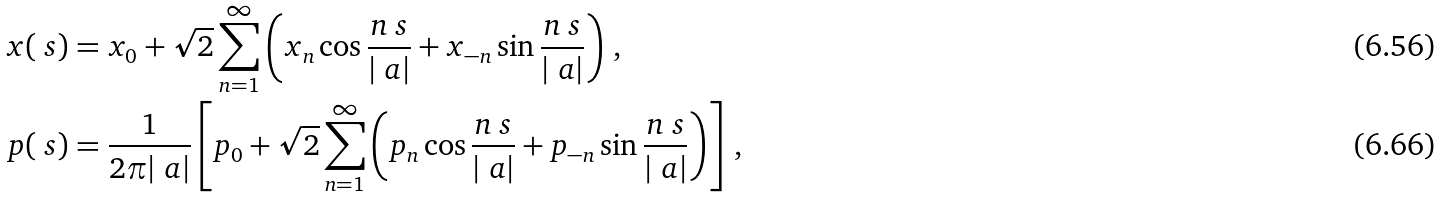<formula> <loc_0><loc_0><loc_500><loc_500>x ( \ s ) & = x _ { 0 } + \sqrt { 2 } \sum _ { n = 1 } ^ { \infty } \left ( x _ { n } \cos \frac { n \ s } { | \ a | } + x _ { - n } \sin \frac { n \ s } { | \ a | } \right ) \, , \\ p ( \ s ) & = \frac { 1 } { 2 \pi | \ a | } \left [ p _ { 0 } + \sqrt { 2 } \sum _ { n = 1 } ^ { \infty } \left ( p _ { n } \cos \frac { n \ s } { | \ a | } + p _ { - n } \sin \frac { n \ s } { | \ a | } \right ) \right ] \, ,</formula> 